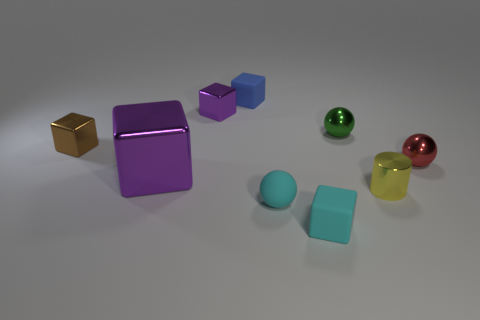Subtract 1 blocks. How many blocks are left? 4 Subtract all gray blocks. Subtract all gray spheres. How many blocks are left? 5 Add 1 tiny yellow shiny cylinders. How many objects exist? 10 Subtract all blocks. How many objects are left? 4 Subtract 1 green spheres. How many objects are left? 8 Subtract all large cyan metal blocks. Subtract all purple metal cubes. How many objects are left? 7 Add 2 matte balls. How many matte balls are left? 3 Add 1 brown blocks. How many brown blocks exist? 2 